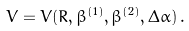Convert formula to latex. <formula><loc_0><loc_0><loc_500><loc_500>V = V ( R , \beta ^ { ( 1 ) } , \beta ^ { ( 2 ) } , \Delta \alpha ) \, .</formula> 